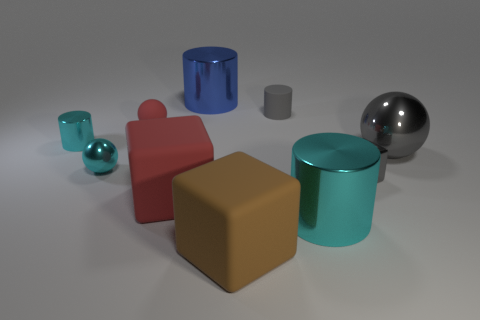Subtract all blocks. How many objects are left? 7 Subtract 0 cyan blocks. How many objects are left? 10 Subtract all tiny cylinders. Subtract all gray things. How many objects are left? 5 Add 1 tiny spheres. How many tiny spheres are left? 3 Add 6 tiny gray things. How many tiny gray things exist? 8 